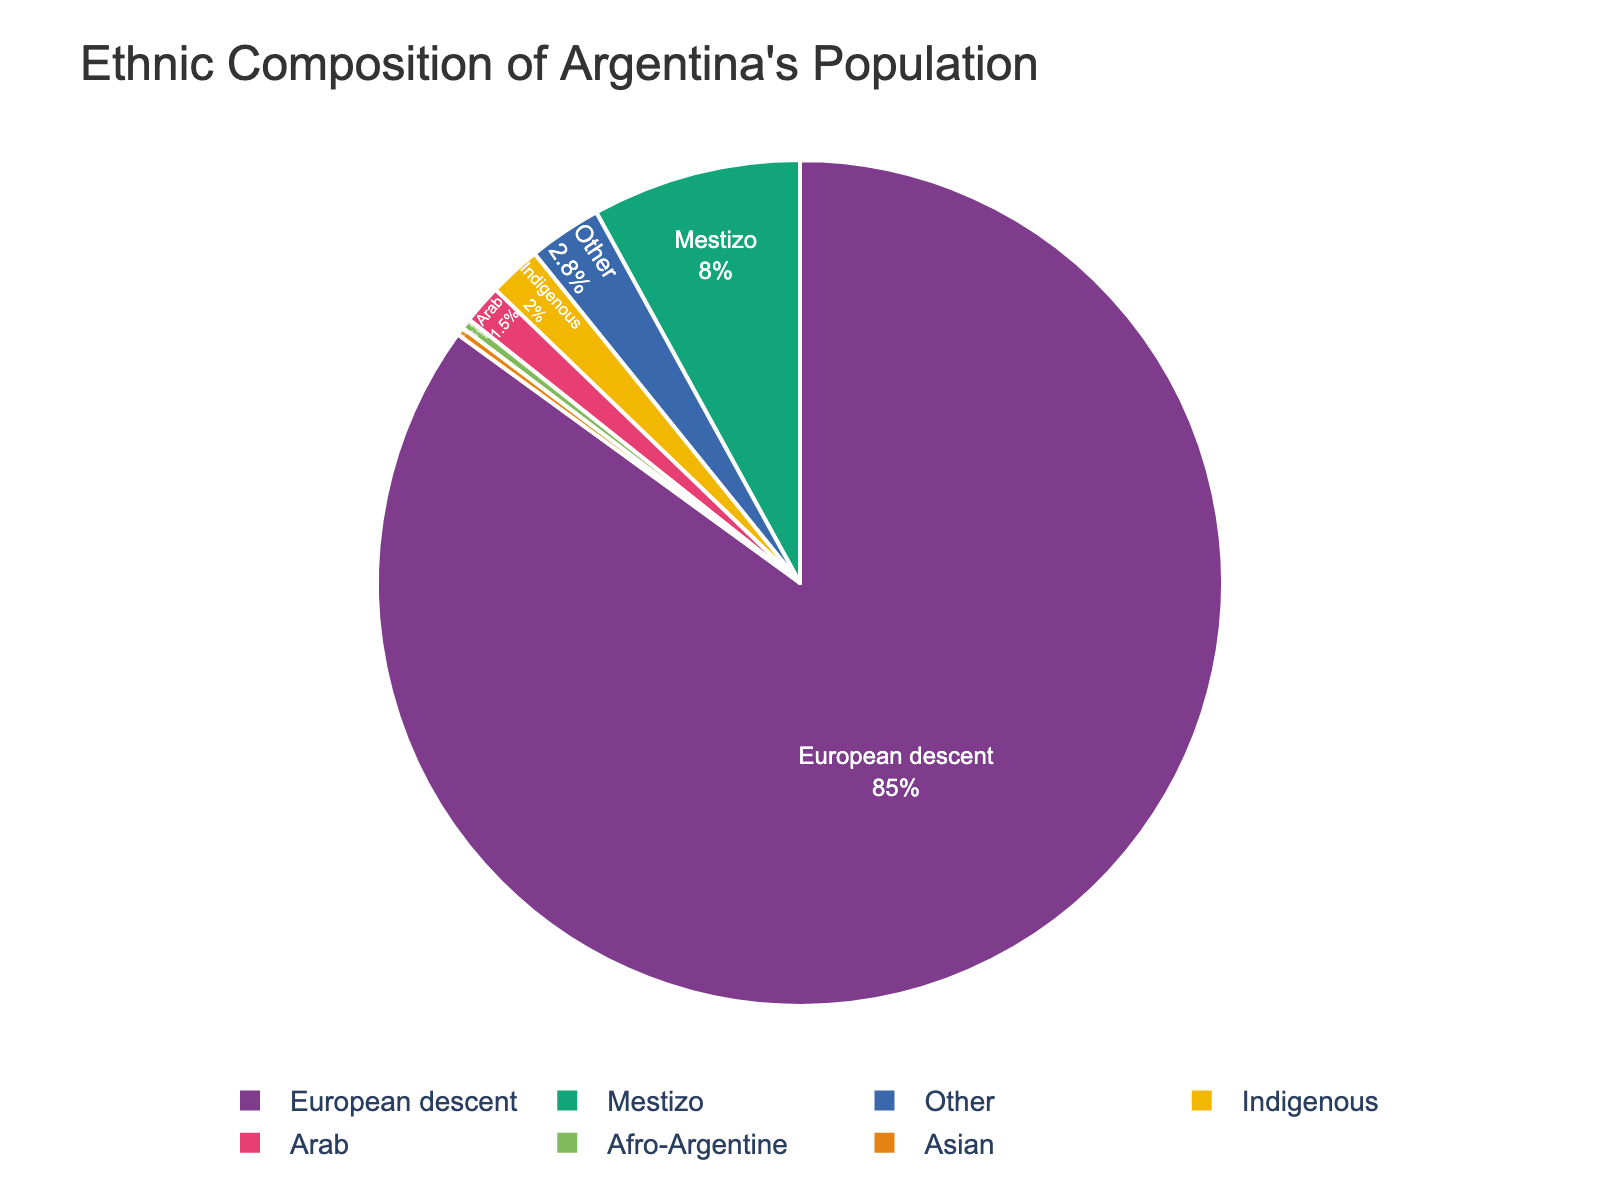What's the combined percentage of Mestizo and Indigenous populations? Add the percentage values for Mestizo (8.0) and Indigenous (2.0). 8.0 + 2.0 = 10.0
Answer: 10.0 Which ethnicity has the smallest percentage? Look at the pie chart and identify the segment representing the smallest percentage, which is the Asian population with 0.3%.
Answer: Asian Are there more people of Arab or Afro-Argentine descent? Compare the percentages: Arabs (1.5%) and Afro-Argentines (0.4%). 1.5% is greater than 0.4%.
Answer: Arab What is the percentage difference between the European descent and the Other category? Subtract the percentage for Other (2.8%) from European descent (85.0%). 85.0% - 2.8% = 82.2%
Answer: 82.2 Which group makes up the largest part of the population? Look at the pie chart and identify the largest segment, which is European descent at 85.0%.
Answer: European descent How much does the Afro-Argentine percentage differ from the Asian percentage? Subtract the percentage for Asian (0.3%) from Afro-Argentine (0.4%). 0.4% - 0.3% = 0.1%
Answer: 0.1 What percentage of the population is made up by minority groups (Arab, Afro-Argentine, and Asian)? Sum the percentages for Arab (1.5%), Afro-Argentine (0.4%), and Asian (0.3%). 1.5% + 0.4% + 0.3% = 2.2%
Answer: 2.2 What is the proportion of European descent compared to Mestizo? Divide the percentage for European descent (85.0%) by the percentage for Mestizo (8.0%). 85.0 / 8.0 = 10.625
Answer: 10.625 